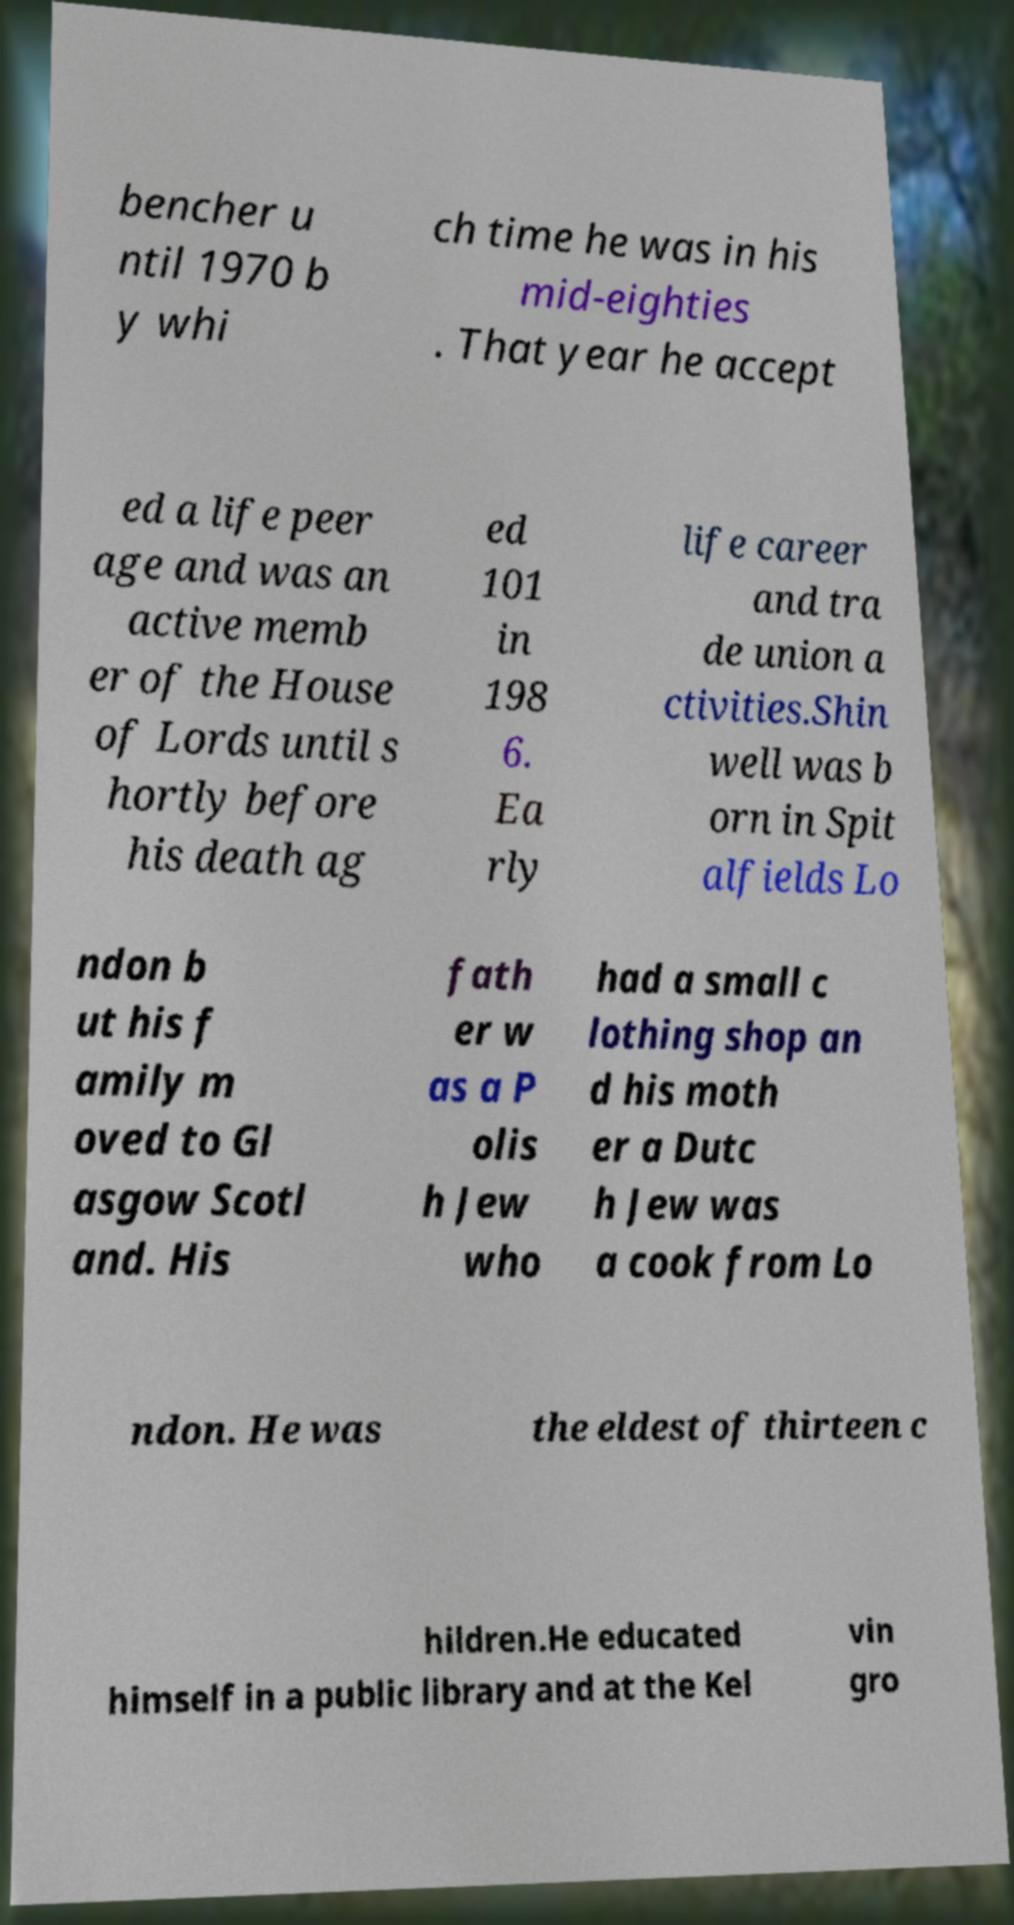Please read and relay the text visible in this image. What does it say? bencher u ntil 1970 b y whi ch time he was in his mid-eighties . That year he accept ed a life peer age and was an active memb er of the House of Lords until s hortly before his death ag ed 101 in 198 6. Ea rly life career and tra de union a ctivities.Shin well was b orn in Spit alfields Lo ndon b ut his f amily m oved to Gl asgow Scotl and. His fath er w as a P olis h Jew who had a small c lothing shop an d his moth er a Dutc h Jew was a cook from Lo ndon. He was the eldest of thirteen c hildren.He educated himself in a public library and at the Kel vin gro 